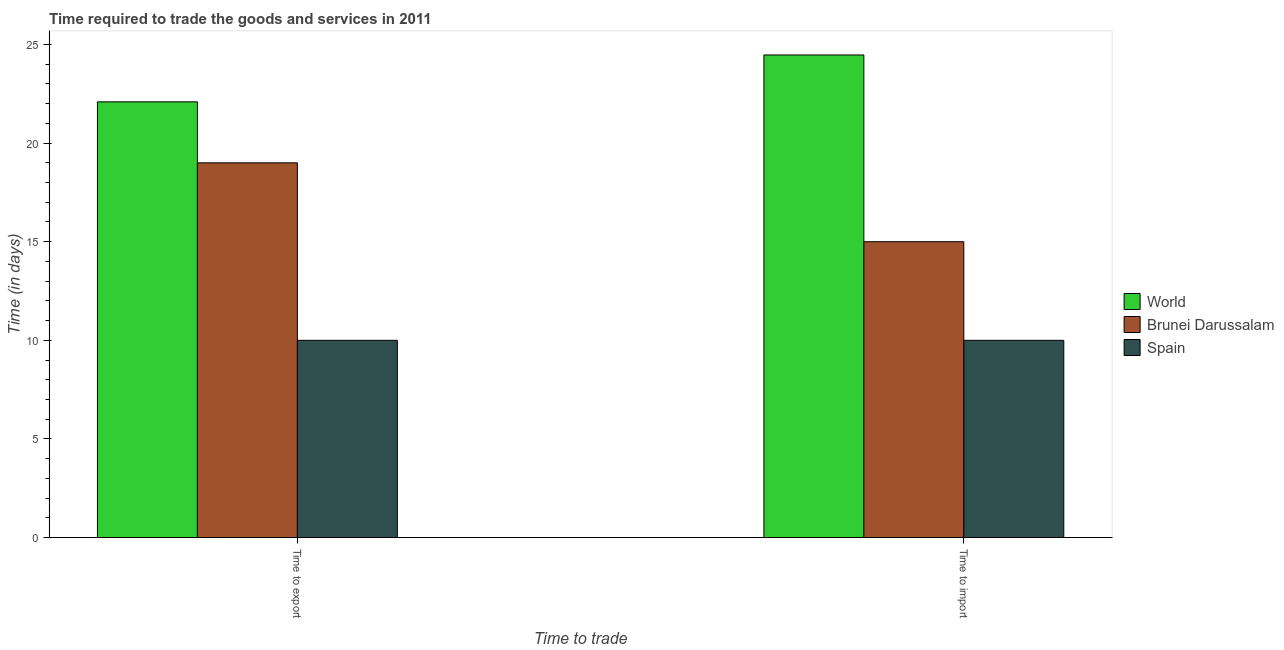How many different coloured bars are there?
Give a very brief answer. 3. How many groups of bars are there?
Your answer should be very brief. 2. How many bars are there on the 2nd tick from the left?
Offer a terse response. 3. What is the label of the 1st group of bars from the left?
Your response must be concise. Time to export. What is the time to import in World?
Give a very brief answer. 24.47. Across all countries, what is the maximum time to import?
Your answer should be very brief. 24.47. Across all countries, what is the minimum time to export?
Your answer should be compact. 10. In which country was the time to import maximum?
Offer a terse response. World. In which country was the time to import minimum?
Offer a very short reply. Spain. What is the total time to import in the graph?
Ensure brevity in your answer.  49.47. What is the difference between the time to import in Brunei Darussalam and that in World?
Offer a terse response. -9.47. What is the difference between the time to import in World and the time to export in Spain?
Provide a succinct answer. 14.47. What is the average time to export per country?
Ensure brevity in your answer.  17.03. What is the ratio of the time to export in Spain to that in World?
Your answer should be very brief. 0.45. Is the time to export in World less than that in Brunei Darussalam?
Your answer should be very brief. No. In how many countries, is the time to export greater than the average time to export taken over all countries?
Your answer should be very brief. 2. How many countries are there in the graph?
Make the answer very short. 3. Does the graph contain any zero values?
Offer a very short reply. No. Does the graph contain grids?
Your answer should be compact. No. Where does the legend appear in the graph?
Your answer should be very brief. Center right. What is the title of the graph?
Make the answer very short. Time required to trade the goods and services in 2011. Does "Lithuania" appear as one of the legend labels in the graph?
Keep it short and to the point. No. What is the label or title of the X-axis?
Offer a very short reply. Time to trade. What is the label or title of the Y-axis?
Your response must be concise. Time (in days). What is the Time (in days) of World in Time to export?
Offer a very short reply. 22.09. What is the Time (in days) of Spain in Time to export?
Provide a succinct answer. 10. What is the Time (in days) of World in Time to import?
Ensure brevity in your answer.  24.47. Across all Time to trade, what is the maximum Time (in days) in World?
Ensure brevity in your answer.  24.47. Across all Time to trade, what is the maximum Time (in days) of Brunei Darussalam?
Provide a succinct answer. 19. Across all Time to trade, what is the maximum Time (in days) of Spain?
Provide a succinct answer. 10. Across all Time to trade, what is the minimum Time (in days) in World?
Your answer should be very brief. 22.09. Across all Time to trade, what is the minimum Time (in days) of Brunei Darussalam?
Your response must be concise. 15. Across all Time to trade, what is the minimum Time (in days) in Spain?
Your response must be concise. 10. What is the total Time (in days) in World in the graph?
Keep it short and to the point. 46.56. What is the total Time (in days) of Spain in the graph?
Offer a very short reply. 20. What is the difference between the Time (in days) in World in Time to export and that in Time to import?
Your answer should be very brief. -2.38. What is the difference between the Time (in days) of Spain in Time to export and that in Time to import?
Offer a terse response. 0. What is the difference between the Time (in days) of World in Time to export and the Time (in days) of Brunei Darussalam in Time to import?
Provide a succinct answer. 7.09. What is the difference between the Time (in days) in World in Time to export and the Time (in days) in Spain in Time to import?
Your answer should be compact. 12.09. What is the average Time (in days) in World per Time to trade?
Your answer should be very brief. 23.28. What is the difference between the Time (in days) in World and Time (in days) in Brunei Darussalam in Time to export?
Offer a terse response. 3.09. What is the difference between the Time (in days) in World and Time (in days) in Spain in Time to export?
Make the answer very short. 12.09. What is the difference between the Time (in days) of Brunei Darussalam and Time (in days) of Spain in Time to export?
Your answer should be compact. 9. What is the difference between the Time (in days) in World and Time (in days) in Brunei Darussalam in Time to import?
Your answer should be very brief. 9.47. What is the difference between the Time (in days) of World and Time (in days) of Spain in Time to import?
Give a very brief answer. 14.47. What is the difference between the Time (in days) in Brunei Darussalam and Time (in days) in Spain in Time to import?
Make the answer very short. 5. What is the ratio of the Time (in days) in World in Time to export to that in Time to import?
Your answer should be compact. 0.9. What is the ratio of the Time (in days) of Brunei Darussalam in Time to export to that in Time to import?
Give a very brief answer. 1.27. What is the ratio of the Time (in days) of Spain in Time to export to that in Time to import?
Make the answer very short. 1. What is the difference between the highest and the second highest Time (in days) in World?
Provide a short and direct response. 2.38. What is the difference between the highest and the second highest Time (in days) in Spain?
Provide a succinct answer. 0. What is the difference between the highest and the lowest Time (in days) in World?
Ensure brevity in your answer.  2.38. What is the difference between the highest and the lowest Time (in days) of Brunei Darussalam?
Your answer should be very brief. 4. What is the difference between the highest and the lowest Time (in days) of Spain?
Offer a terse response. 0. 